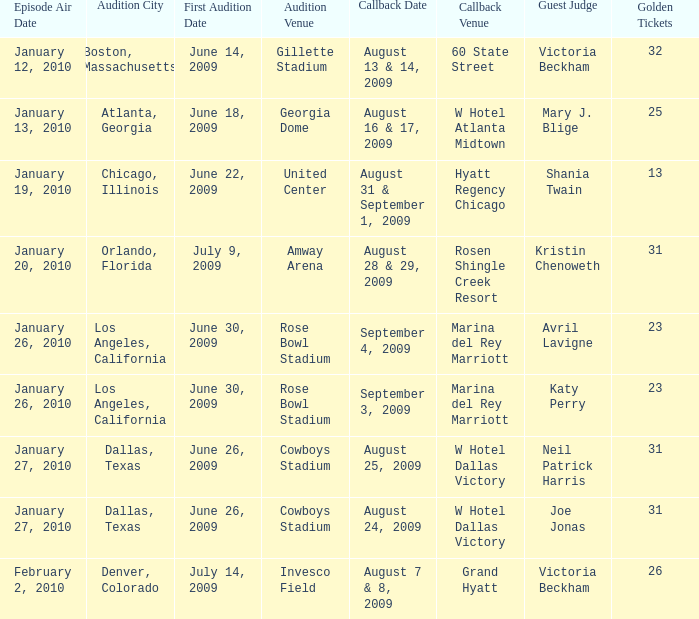On which date is the callback happening at amway arena? August 28 & 29, 2009. 